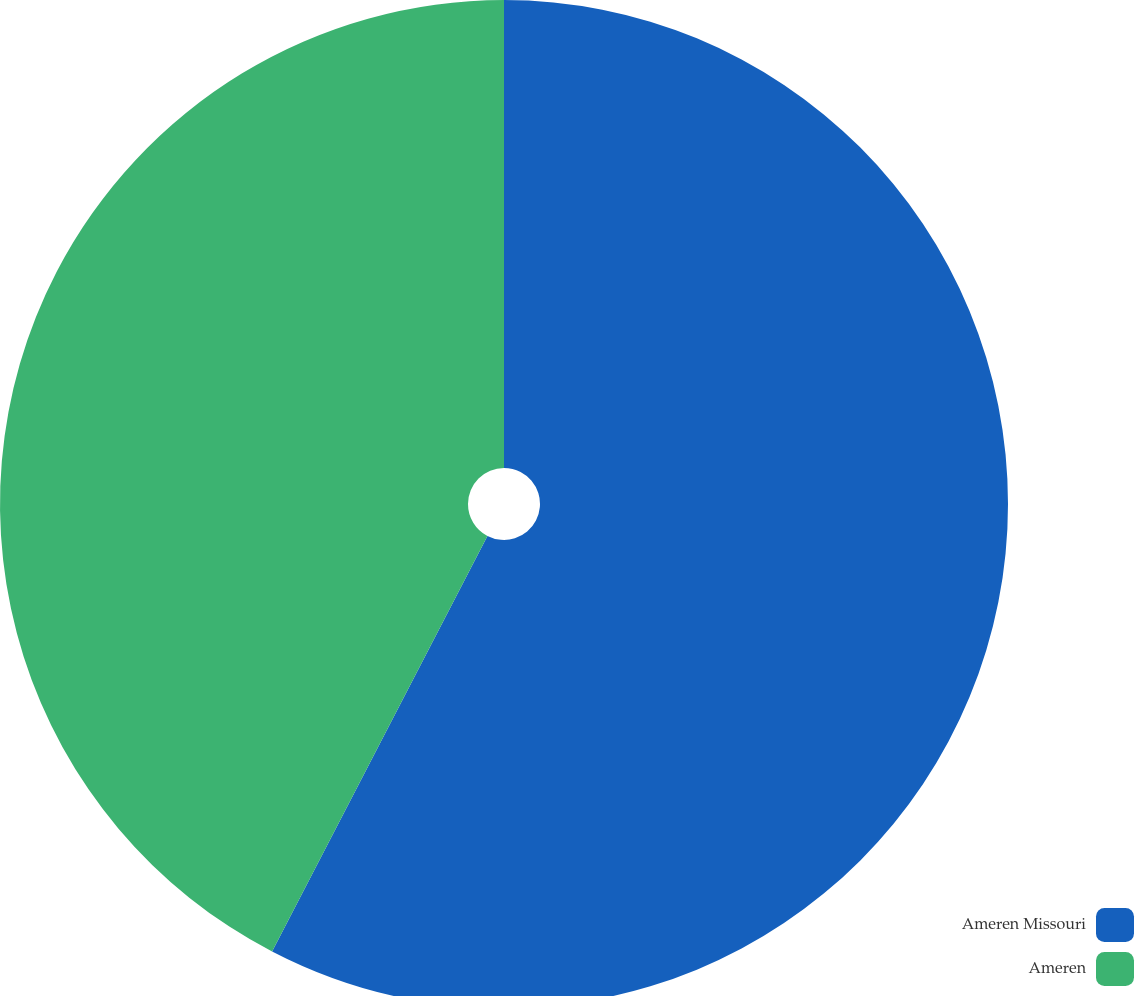Convert chart to OTSL. <chart><loc_0><loc_0><loc_500><loc_500><pie_chart><fcel>Ameren Missouri<fcel>Ameren<nl><fcel>57.61%<fcel>42.39%<nl></chart> 